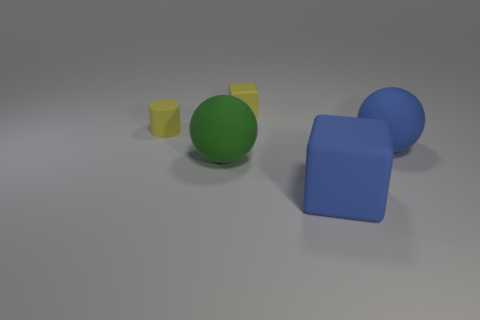What number of yellow cylinders are left of the tiny object that is in front of the tiny yellow rubber block behind the large rubber block?
Provide a short and direct response. 0. Is the shape of the blue thing behind the green matte ball the same as  the green object?
Offer a very short reply. Yes. There is a large rubber ball that is to the left of the yellow matte block; are there any yellow things to the left of it?
Provide a short and direct response. Yes. What number of blue rubber objects are there?
Provide a short and direct response. 2. There is a thing that is to the right of the green matte ball and to the left of the blue rubber cube; what is its color?
Provide a short and direct response. Yellow. What size is the blue matte thing that is the same shape as the green rubber object?
Offer a very short reply. Large. How many yellow matte cylinders are the same size as the yellow rubber cube?
Keep it short and to the point. 1. Are there any small rubber things to the left of the green object?
Your answer should be very brief. Yes. The blue cube that is made of the same material as the yellow cylinder is what size?
Provide a succinct answer. Large. How many things have the same color as the big rubber block?
Offer a terse response. 1. 